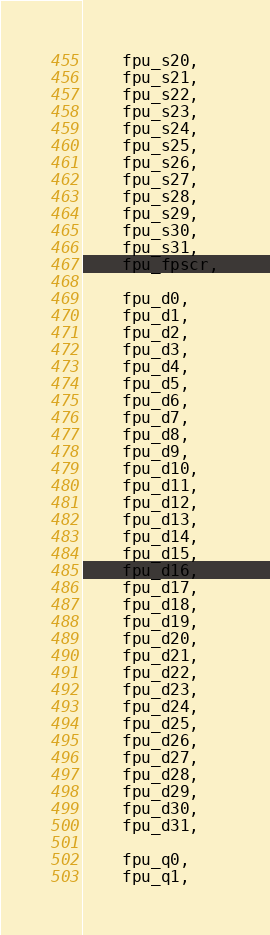<code> <loc_0><loc_0><loc_500><loc_500><_C_>    fpu_s20,
    fpu_s21,
    fpu_s22,
    fpu_s23,
    fpu_s24,
    fpu_s25,
    fpu_s26,
    fpu_s27,
    fpu_s28,
    fpu_s29,
    fpu_s30,
    fpu_s31,
    fpu_fpscr,

    fpu_d0,
    fpu_d1,
    fpu_d2,
    fpu_d3,
    fpu_d4,
    fpu_d5,
    fpu_d6,
    fpu_d7,
    fpu_d8,
    fpu_d9,
    fpu_d10,
    fpu_d11,
    fpu_d12,
    fpu_d13,
    fpu_d14,
    fpu_d15,
    fpu_d16,
    fpu_d17,
    fpu_d18,
    fpu_d19,
    fpu_d20,
    fpu_d21,
    fpu_d22,
    fpu_d23,
    fpu_d24,
    fpu_d25,
    fpu_d26,
    fpu_d27,
    fpu_d28,
    fpu_d29,
    fpu_d30,
    fpu_d31,

    fpu_q0,
    fpu_q1,</code> 